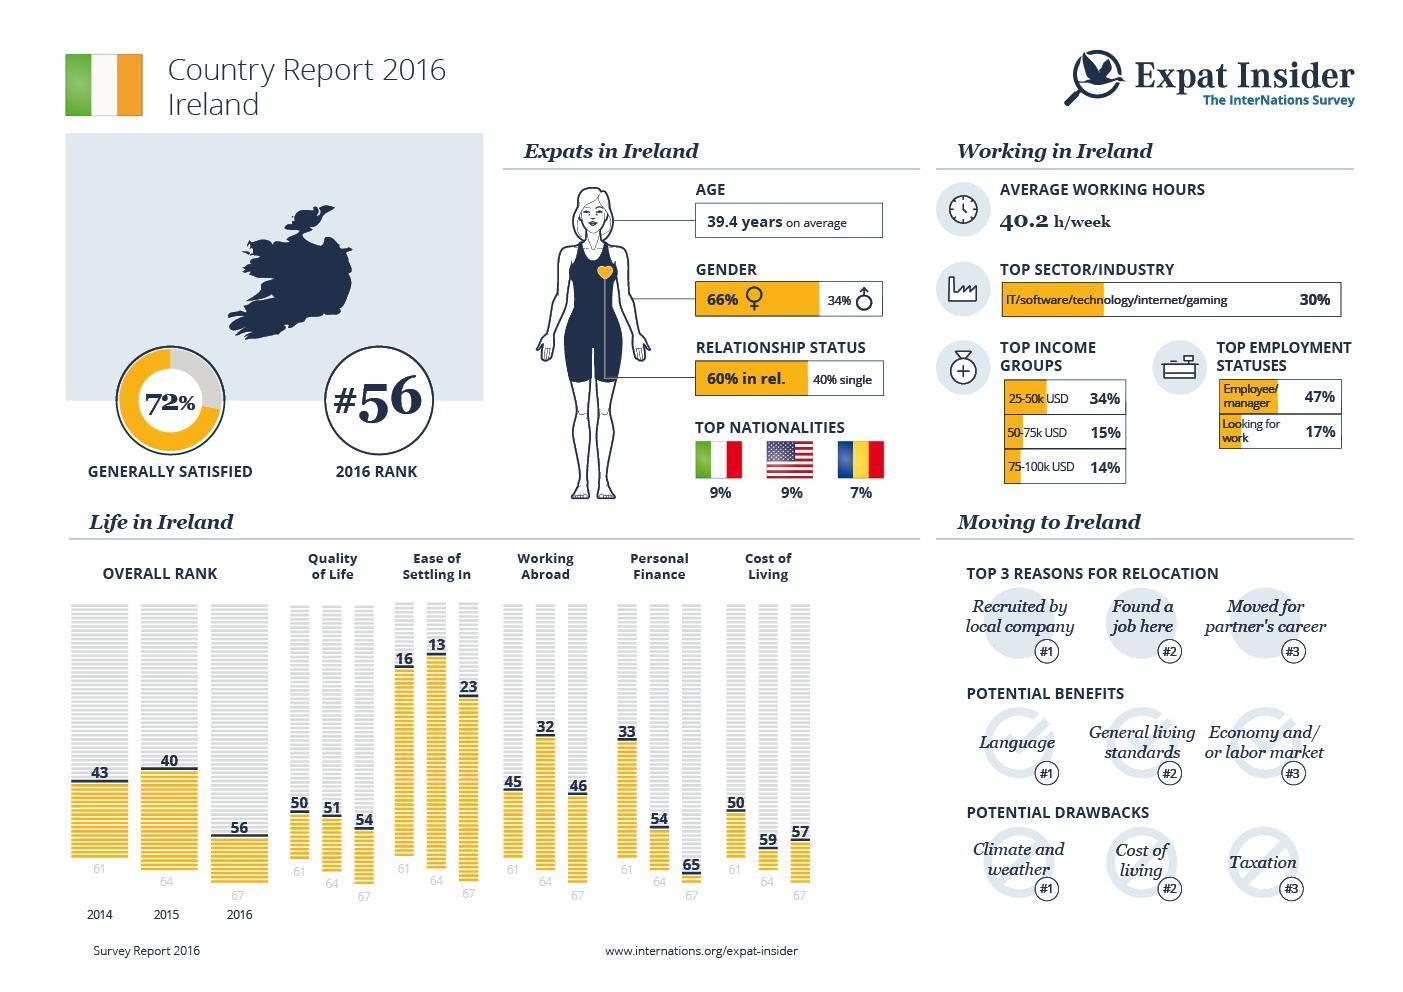what is the most common salary range in Ireland?
Answer the question with a short phrase. 25-50K According to the survey what is the second most considerable drawback while moving to Ireland? cost of living what is the total percentage of people with salary between 25K and 100K? 63 According to the survey what is the second most considerable benefit while moving to Ireland? general living standard what is the total percentage of people with salary between 50K and 100K? 29% 